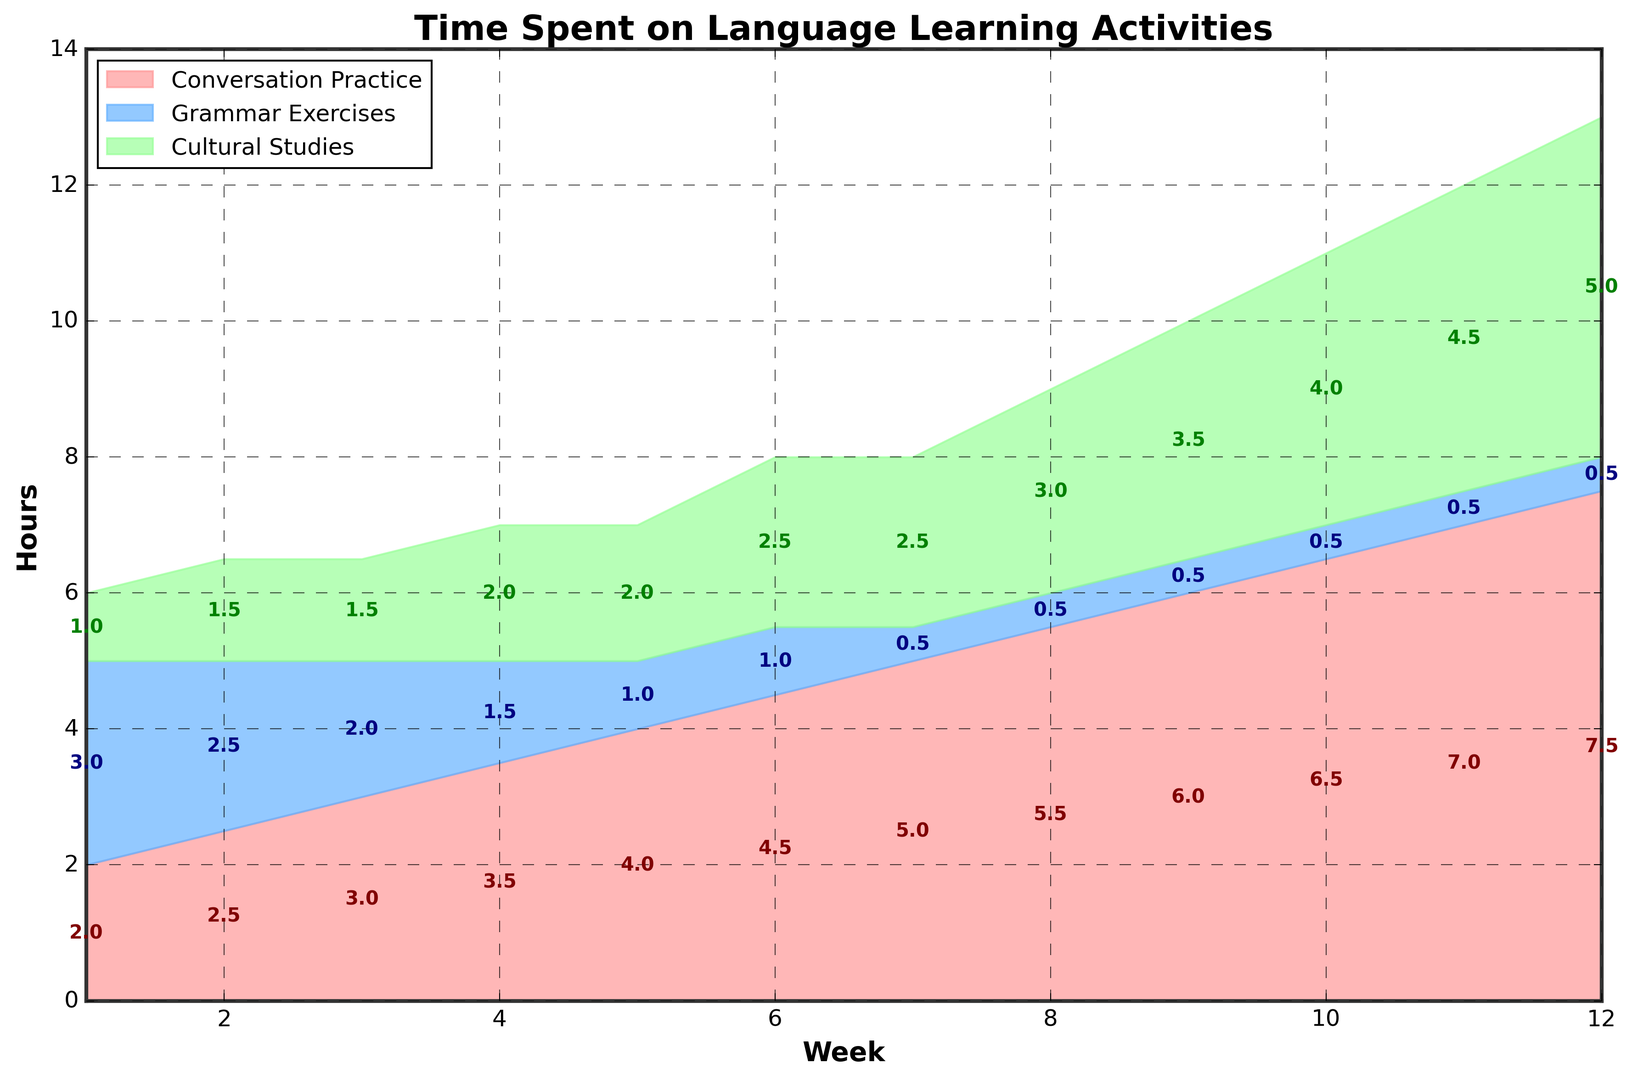What's the total amount of time spent on all activities in week 4? To calculate the total amount of time spent on all activities in week 4, sum the time spent on conversation practice, grammar exercises, and cultural studies. In week 4 these are 3.5, 1.5, and 2 hours respectively. Hence, 3.5 + 1.5 + 2 = 7.0 hours.
Answer: 7.0 hours In which week does conversation practice equal grammar exercises? By examining the chart, identify when the areas for "Conversation Practice" and "Grammar Exercises" are the same height. This happens in week 2 where both are 2.5 hours.
Answer: Week 2 Which activity has the largest increase from week 1 to week 12? To determine the largest increase, subtract the week 1 value from the week 12 value for each activity. Conversation practice increases from 2 to 7.5 (5.5 hours), grammar exercises decrease from 3 to 0.5 (-2.5 hours), cultural studies increase from 1 to 5 (4 hours). So, conversation practice has the largest increase of 5.5 hours.
Answer: Conversation Practice What is the shortest amount of time allocated to cultural studies in any week? The shortest time spent on cultural studies can be seen by identifying the lowest point of the green-colored area on the chart. Cultural studies is 1 hour in week 1.
Answer: 1 hour Which week shows the peak in grammar exercises? Identify the highest point reached by the blue-colored area representing grammar exercises. The peak does not have to be a single point at the top, it could be a plateau. The maximum of grammar exercises is 3 hours in week 1.
Answer: Week 1 What's the difference in time spent on cultural studies between week 10 and week 5? To find the difference, subtract the time spent on cultural studies in week 5 from the time spent in week 10: 4 hours (week 10) - 2 hours (week 5) = 2 hours
Answer: 2 hours During which weeks does cultural studies occupy less than 2 hours? Examine the green-colored area and identify weeks where cultural studies are below the 2-hour mark. Cultural studies is less than 2 hours in weeks 1, 2, 3, and 4.
Answer: Weeks 1, 2, 3, 4 What’s the cumulative total of hours spent on grammar exercises by week 8? Sum the hours of grammar exercises up to week 8: 3 + 2.5 + 2 + 1.5 + 1 + 1 + 0.5 + 0.5 = 12 hours
Answer: 12 hours Is there any week where time spent on conversation practice is exactly twice the amount spent on cultural studies? We check for each week if the hours for conversation practice is double those of cultural studies. In week 1, it's not (2 vs. 1). Repeat this check for all weeks. Notably, in week 12, conversation practice is 7.5 hours and cultural studies is 5 hours, which does not match. Hence, no such week.
Answer: No Which activity consistently decreases over time? Identify the trend of each activity, focusing on whether the trend is always downward. Grammar exercises consistently decrease from 3 hours in week 1 to 0.5 hours by week 12.
Answer: Grammar exercises 